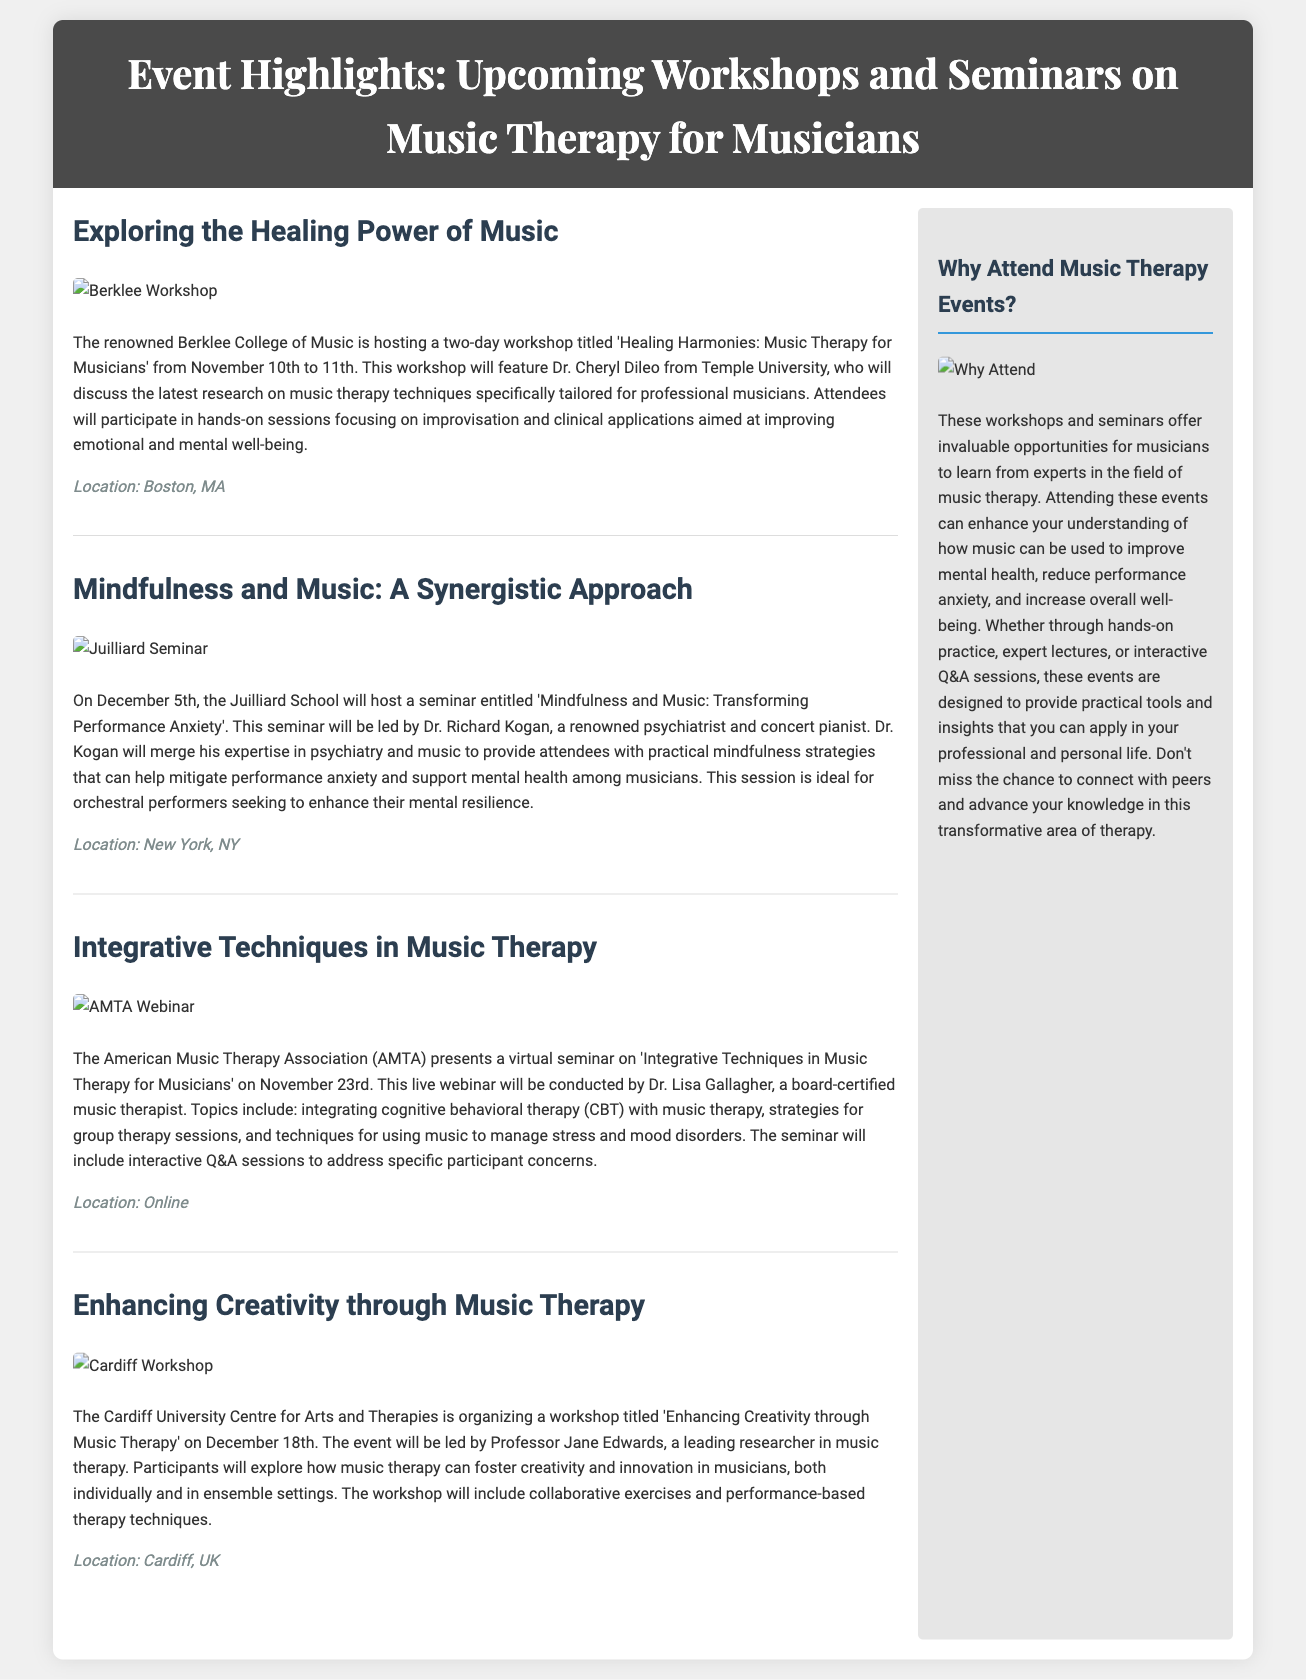what is the title of the workshop at Berklee College of Music? The title of the workshop is mentioned in the article about it, which is 'Healing Harmonies: Music Therapy for Musicians'.
Answer: Healing Harmonies: Music Therapy for Musicians who is leading the seminar at Juilliard School? The document states that the seminar will be led by Dr. Richard Kogan.
Answer: Dr. Richard Kogan when is the virtual seminar presented by the American Music Therapy Association? The document provides the specific date of the seminar, which is November 23rd.
Answer: November 23rd what is the main focus of the Cardiff University workshop? The focus of the workshop is indicated in the title and description, which is enhancing creativity through music therapy.
Answer: Enhancing Creativity through Music Therapy where is the location for the workshop conducted by Professor Jane Edwards? The document mentions the location for this workshop as Cardiff, UK.
Answer: Cardiff, UK what type of event is scheduled at Juilliard School? The type of event mentioned for Juilliard School is a seminar.
Answer: Seminar what is a key benefit of attending these workshops and seminars? The document specifies that these events can enhance understanding of how music improves mental health.
Answer: improve mental health what date does the workshop at Berklee College occur? According to the document, the workshop dates are from November 10th to 11th.
Answer: November 10th to 11th how can participants benefit from the American Music Therapy Association's event? The document explains that the seminar will include interactive Q&A sessions to address specific participant concerns.
Answer: interactive Q&A sessions 